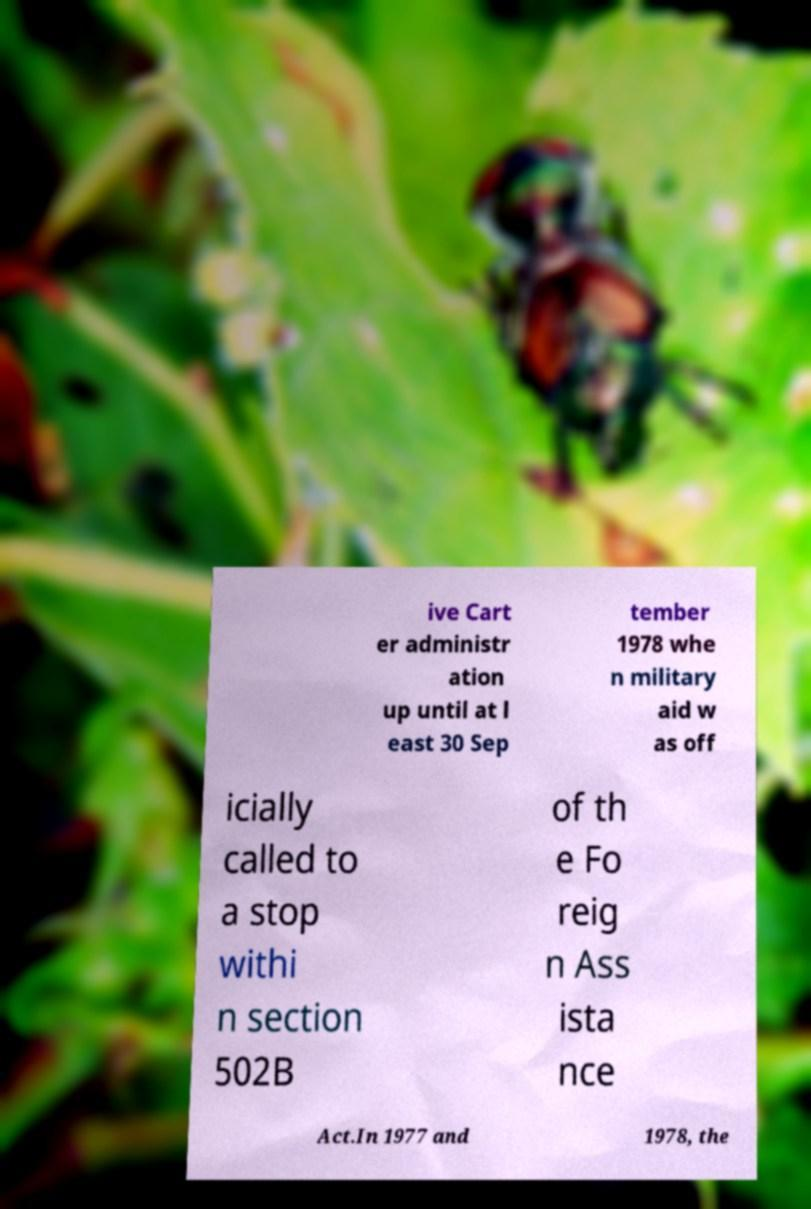Can you read and provide the text displayed in the image?This photo seems to have some interesting text. Can you extract and type it out for me? ive Cart er administr ation up until at l east 30 Sep tember 1978 whe n military aid w as off icially called to a stop withi n section 502B of th e Fo reig n Ass ista nce Act.In 1977 and 1978, the 